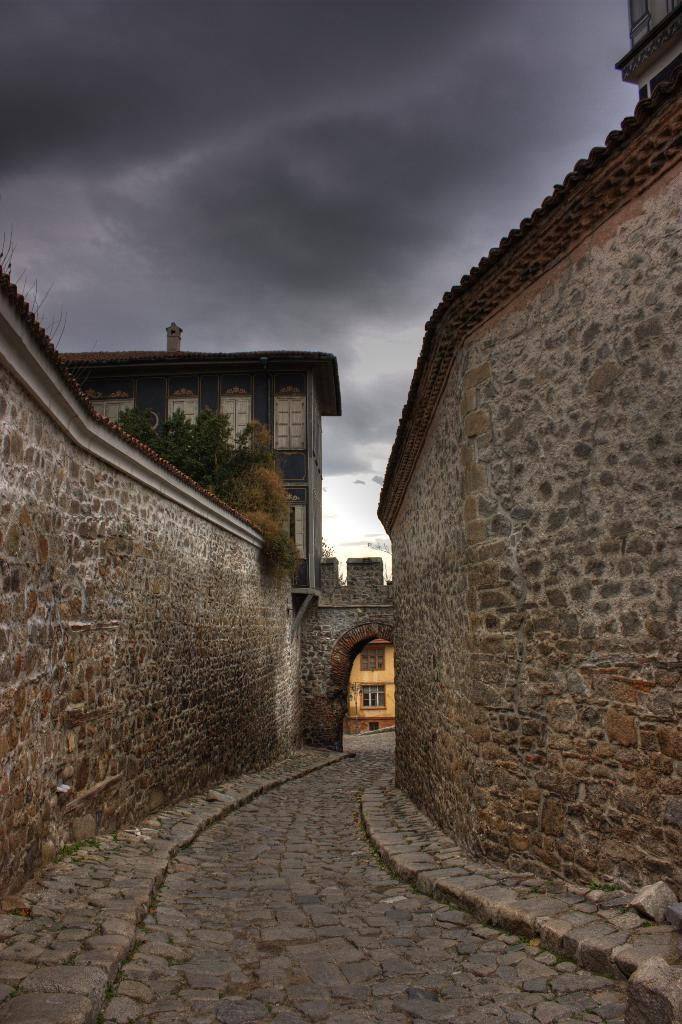Where was the image taken? The image was taken on a road. What can be seen at the bottom of the image? There is a path at the bottom of the image. What surrounds the path on both sides? There are walls on both the left and right sides of the image. What structure is in the front of the image? There is a building in the front of the image. What is visible at the top of the image? The sky is visible at the top of the image. What type of wine is being served at the restaurant in the image? There is no restaurant or wine present in the image; it features a road, path, walls, a building, and the sky. 